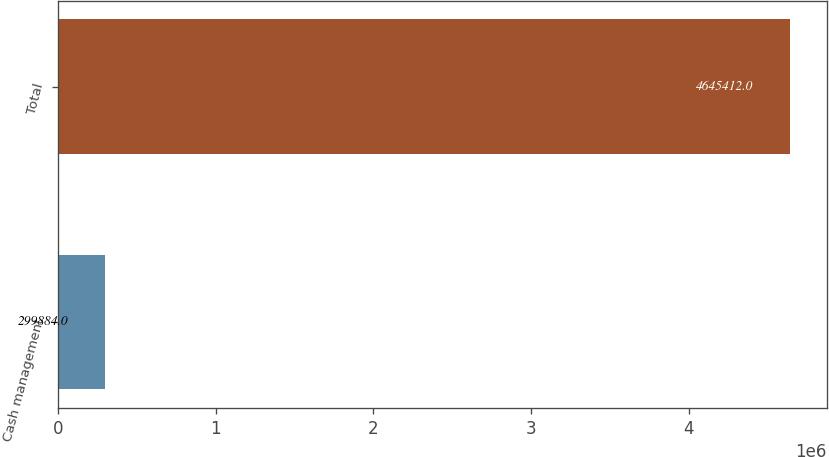Convert chart to OTSL. <chart><loc_0><loc_0><loc_500><loc_500><bar_chart><fcel>Cash management<fcel>Total<nl><fcel>299884<fcel>4.64541e+06<nl></chart> 